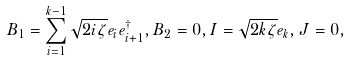<formula> <loc_0><loc_0><loc_500><loc_500>B _ { 1 } = \sum _ { i = 1 } ^ { k - 1 } \sqrt { 2 i \zeta } e _ { i } e _ { i + 1 } ^ { \dag } , B _ { 2 } = 0 , I = \sqrt { 2 k \zeta } e _ { k } , J = 0 ,</formula> 